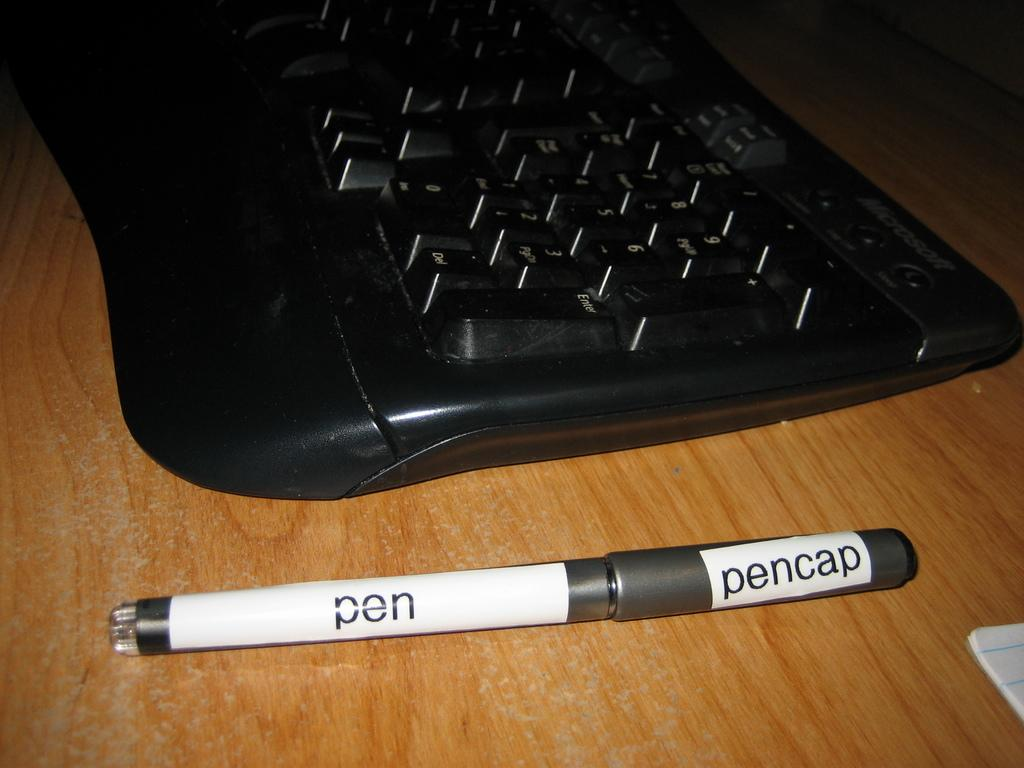What is the color of the table in the image? The table in the image is brown colored. What object is placed on the table? There is a black colored keyboard on the table. What stationery item is present on the table? There is a pen on the table. Where is the book located in the image? The book is in the bottom right corner of the image. How does the tank push the letter in the image? There is no tank or letter present in the image. 